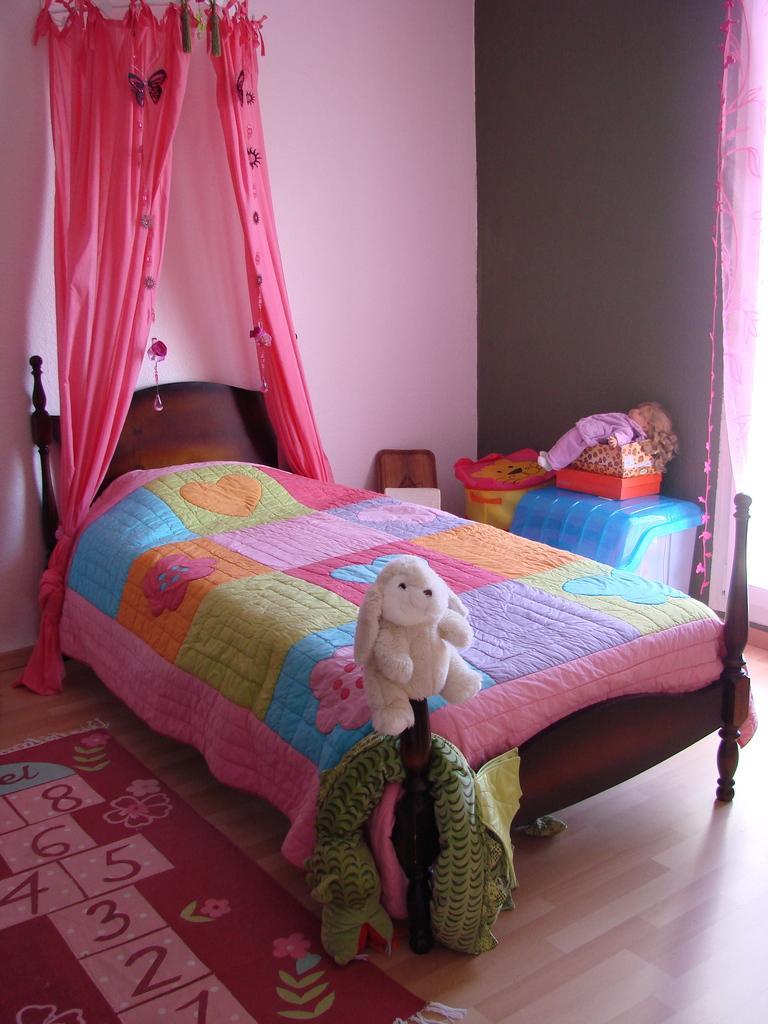Can you describe this image briefly? In this image I can see a bed, a teddy bear, a container and curtains. 